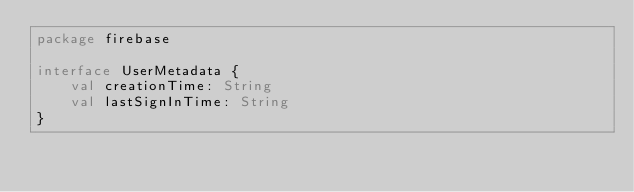<code> <loc_0><loc_0><loc_500><loc_500><_Kotlin_>package firebase

interface UserMetadata {
    val creationTime: String
    val lastSignInTime: String
}</code> 